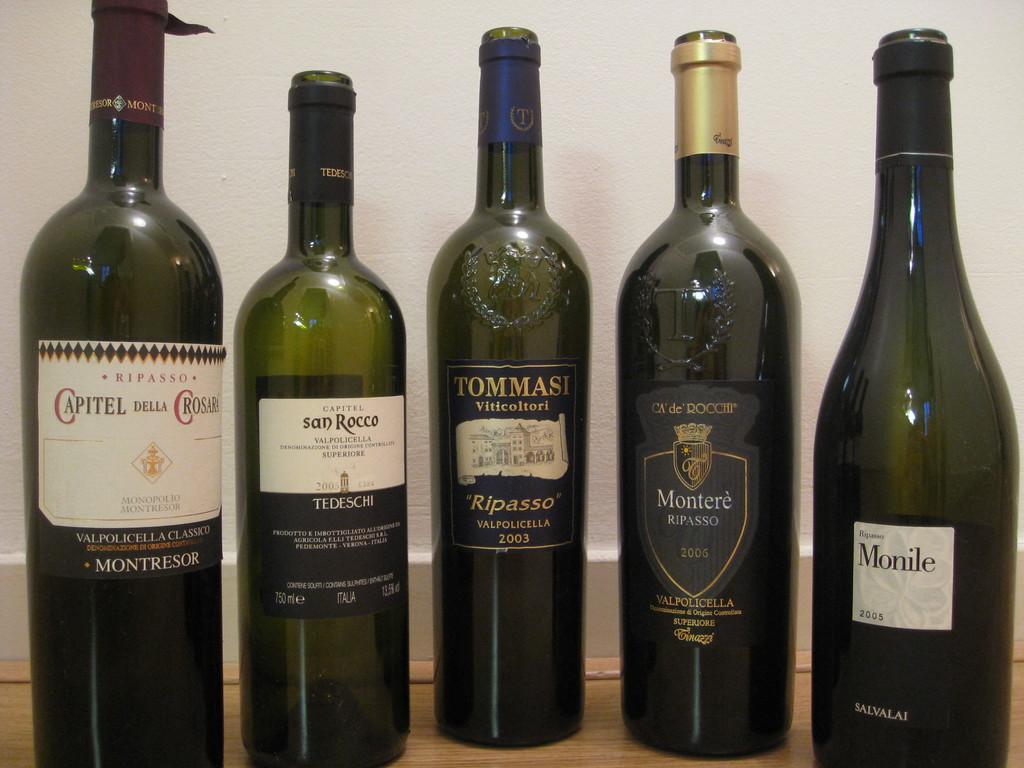What year is the middle bottle from?
Offer a very short reply. 2003. What year is on the bottle on the far right?
Give a very brief answer. 2005. 